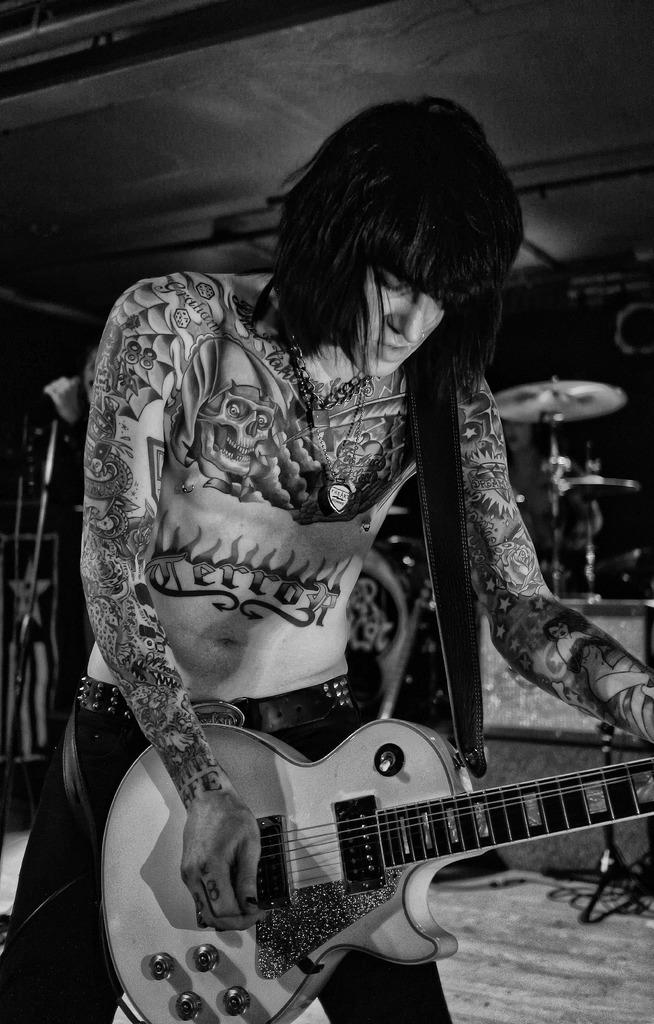What is the main subject of the image? There is a person in the image. What is the person doing in the image? The person is standing and holding a guitar. Can you describe any unique features of the person? The person has tattoos on their body. What else can be seen in the image related to music? There are multiple musical instruments visible in the background of the image. What type of light can be seen illuminating the cemetery in the image? There is no cemetery present in the image, and therefore no light illuminating it. 